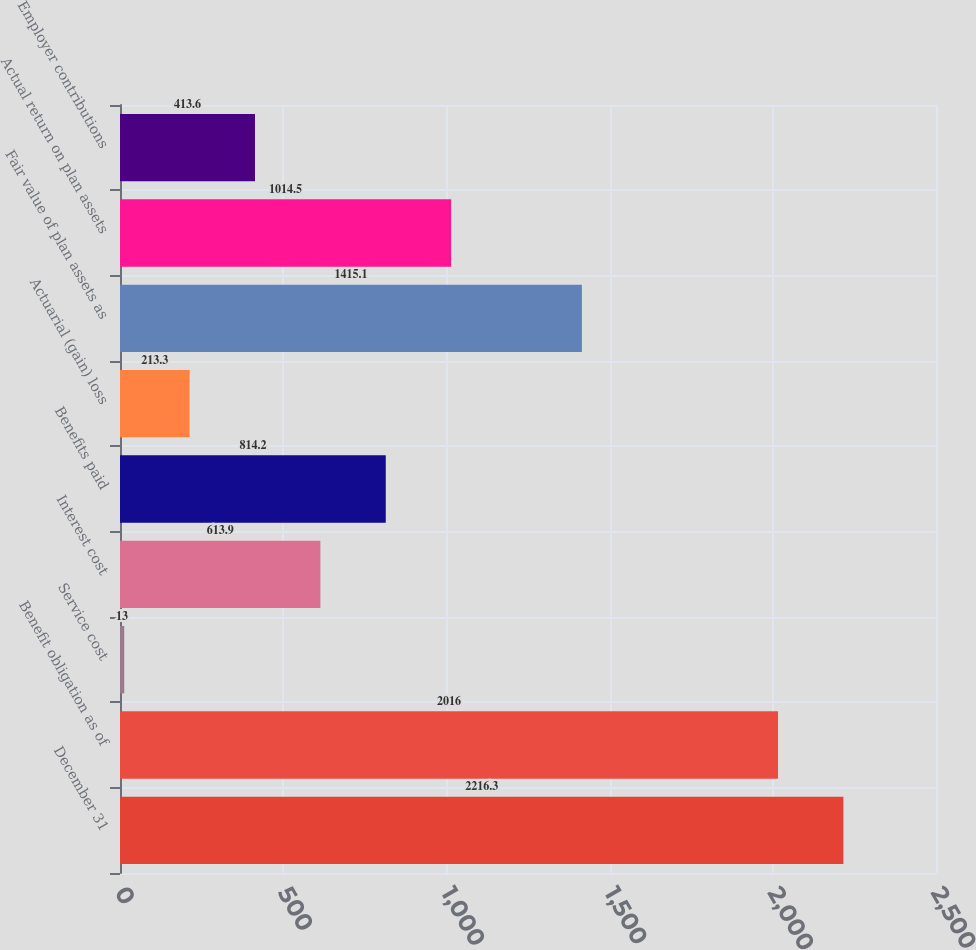Convert chart. <chart><loc_0><loc_0><loc_500><loc_500><bar_chart><fcel>December 31<fcel>Benefit obligation as of<fcel>Service cost<fcel>Interest cost<fcel>Benefits paid<fcel>Actuarial (gain) loss<fcel>Fair value of plan assets as<fcel>Actual return on plan assets<fcel>Employer contributions<nl><fcel>2216.3<fcel>2016<fcel>13<fcel>613.9<fcel>814.2<fcel>213.3<fcel>1415.1<fcel>1014.5<fcel>413.6<nl></chart> 